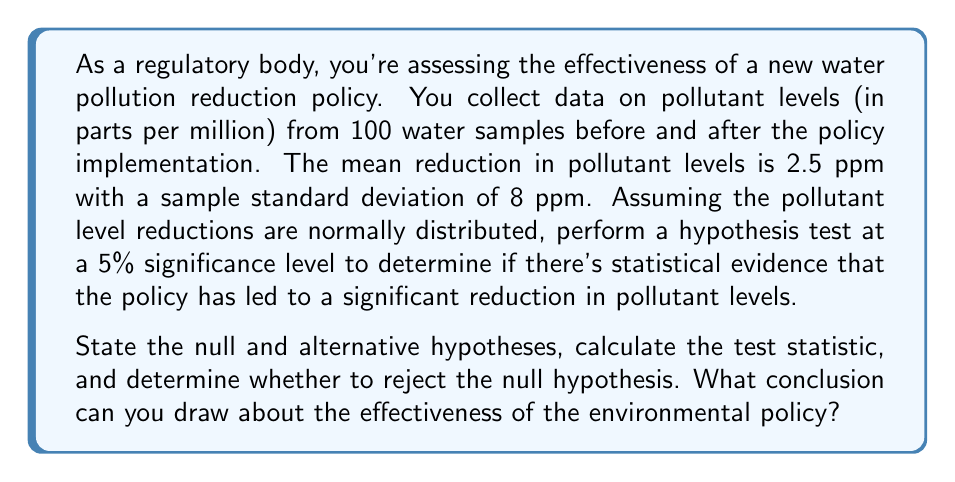What is the answer to this math problem? To assess the effectiveness of the environmental policy, we'll use a one-sample t-test. Let's follow these steps:

1) State the hypotheses:
   $H_0: \mu = 0$ (Null hypothesis: The policy has no effect on pollutant levels)
   $H_a: \mu > 0$ (Alternative hypothesis: The policy reduces pollutant levels)

2) Choose the significance level: 
   $\alpha = 0.05$ (5% significance level, as given in the question)

3) Calculate the test statistic:
   The test statistic for a one-sample t-test is:

   $$t = \frac{\bar{x} - \mu_0}{s/\sqrt{n}}$$

   Where:
   $\bar{x}$ = sample mean = 2.5 ppm
   $\mu_0$ = hypothesized population mean = 0 ppm (under $H_0$)
   $s$ = sample standard deviation = 8 ppm
   $n$ = sample size = 100

   Plugging in the values:

   $$t = \frac{2.5 - 0}{8/\sqrt{100}} = \frac{2.5}{8/10} = \frac{2.5}{0.8} = 3.125$$

4) Determine the critical value:
   For a one-tailed test with $\alpha = 0.05$ and df = 99, the critical t-value is approximately 1.660 (from t-distribution table)

5) Decision rule:
   Reject $H_0$ if $t > 1.660$

6) Conclusion:
   Since $3.125 > 1.660$, we reject the null hypothesis.

This means there is statistical evidence to support the claim that the environmental policy has led to a significant reduction in pollutant levels. The p-value for this test would be less than 0.05, indicating strong evidence against the null hypothesis.
Answer: Reject the null hypothesis. There is statistically significant evidence at the 5% level to conclude that the environmental policy has been effective in reducing pollutant levels. 